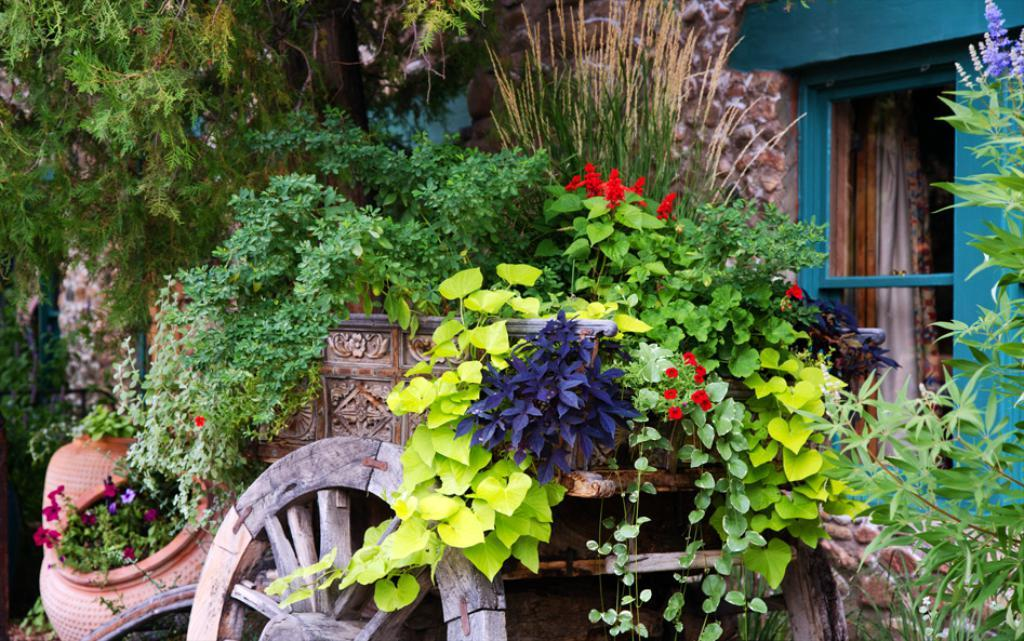What type of living organisms can be seen in the image? Plants and colorful flowers are visible in the image. Where are the plants and flowers located? The plants and flowers are on a cart in the image. What can be seen in the background of the image? There is a building in the image, and a curtain is visible in the building. What emotion is the duck displaying in the image? There are no ducks present in the image, so it is not possible to determine the emotion of a duck. 